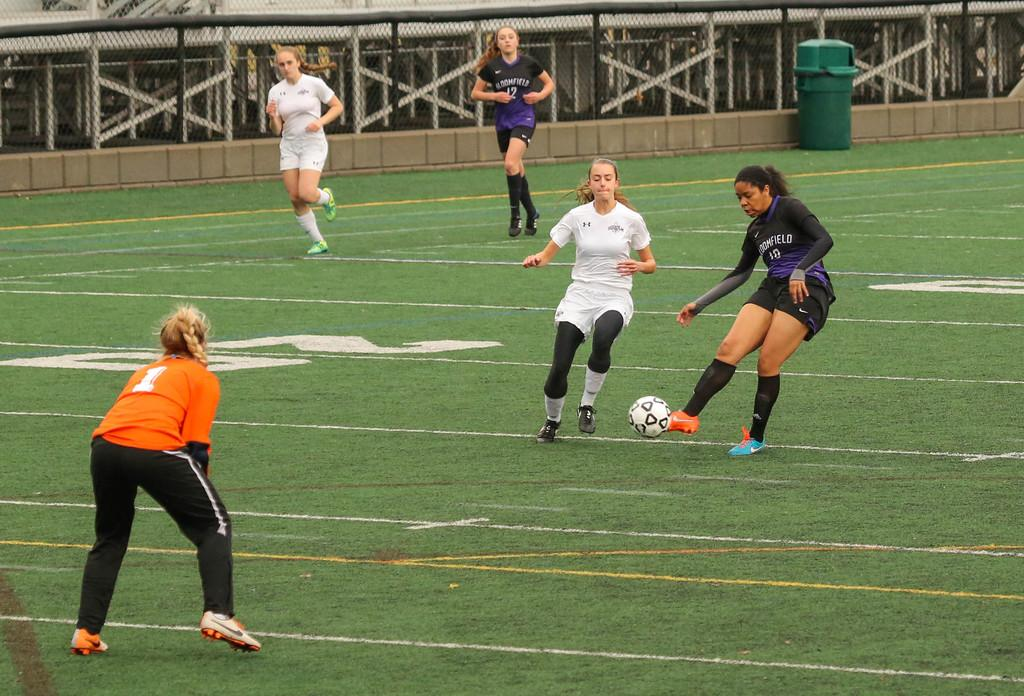How many people are in the image? There are five women in the image. What are the women doing in the image? The women are playing with a ball. What can be seen in the background of the image? There is a dustbin and a railing in the background of the image. What is the name of the daughter of the woman holding the ball in the image? There is no mention of a daughter or any names in the image. 